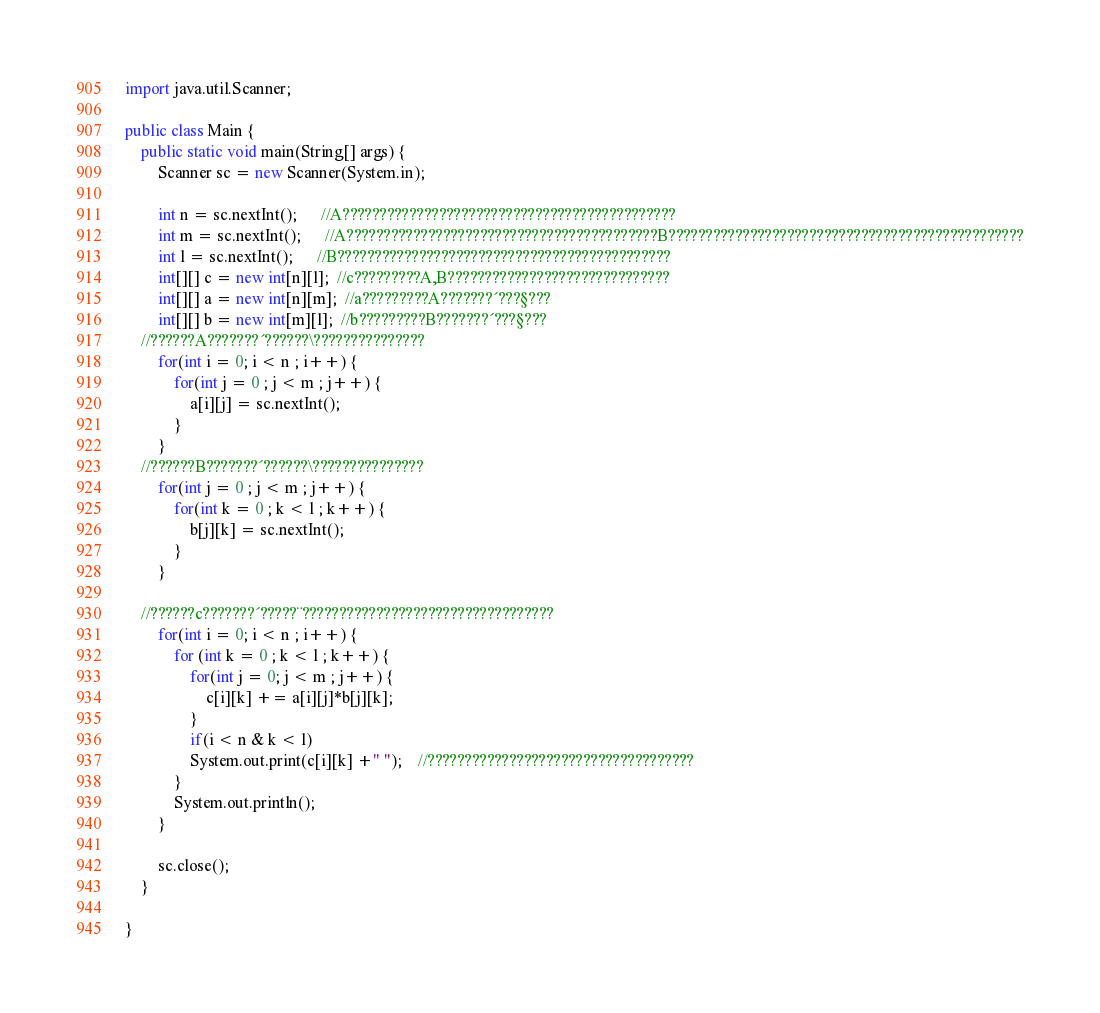<code> <loc_0><loc_0><loc_500><loc_500><_Java_>import java.util.Scanner;

public class Main {
	public static void main(String[] args) {
		Scanner sc = new Scanner(System.in);
		
		int n = sc.nextInt();      //A?????????????????????????????????????????????
		int m = sc.nextInt();      //A??????????????????????????????????????????B????????????????????????????????????????????????
		int l = sc.nextInt();      //B?????????????????????????????????????????????
		int[][] c = new int[n][l];  //c?????????A,B??????????????????????????????
		int[][] a = new int[n][m];  //a?????????A???????´???§???
		int[][] b = new int[m][l];  //b?????????B???????´???§???
	//??????A???????´??????\???????????????	
		for(int i = 0; i < n ; i++) {
			for(int j = 0 ; j < m ; j++) {
				a[i][j] = sc.nextInt();
			}
		}
    //??????B???????´??????\???????????????		
		for(int j = 0 ; j < m ; j++) {
			for(int k = 0 ; k < l ; k++) {
				b[j][k] = sc.nextInt();
			}
		}
		
	//??????c???????´?????¨??????????????????????????????????		
		for(int i = 0; i < n ; i++) {
			for (int k = 0 ; k < l ; k++) {
				for(int j = 0; j < m ; j++) {
					c[i][k] += a[i][j]*b[j][k];
				}
				if(i < n & k < l)
				System.out.print(c[i][k] +" "); 	//????????????????????????????????????
			}
			System.out.println();
		}
		
		sc.close();
	}

}</code> 